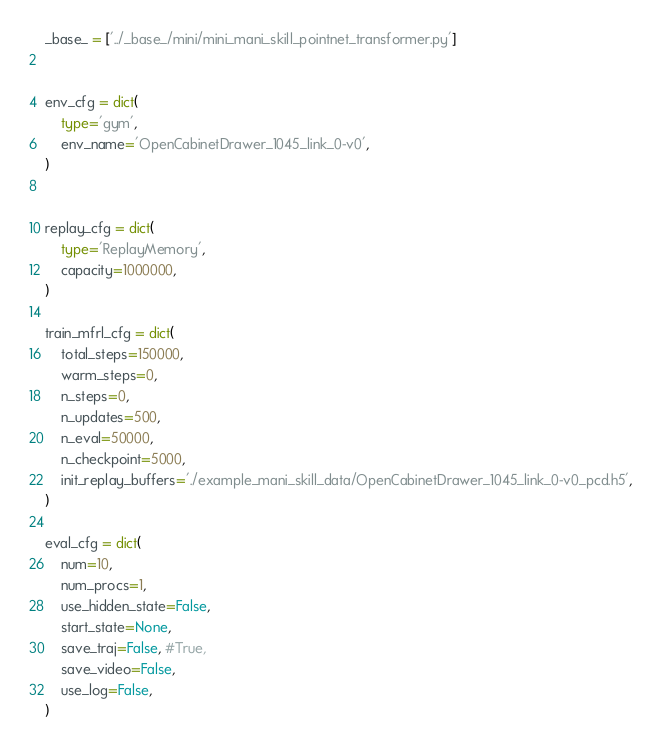Convert code to text. <code><loc_0><loc_0><loc_500><loc_500><_Python_>_base_ = ['../_base_/mini/mini_mani_skill_pointnet_transformer.py']


env_cfg = dict(
    type='gym',
    env_name='OpenCabinetDrawer_1045_link_0-v0',
)


replay_cfg = dict(
    type='ReplayMemory',
    capacity=1000000,
)

train_mfrl_cfg = dict(
    total_steps=150000,
    warm_steps=0,
    n_steps=0,
    n_updates=500,
    n_eval=50000,
    n_checkpoint=5000,
    init_replay_buffers='./example_mani_skill_data/OpenCabinetDrawer_1045_link_0-v0_pcd.h5',
)

eval_cfg = dict(
    num=10,
    num_procs=1,
    use_hidden_state=False,
    start_state=None,
    save_traj=False, #True,
    save_video=False,
    use_log=False,
)
</code> 